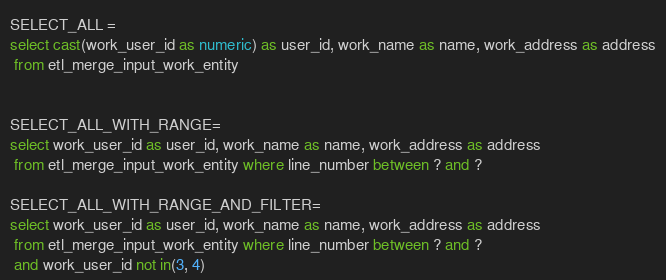<code> <loc_0><loc_0><loc_500><loc_500><_SQL_>SELECT_ALL =
select cast(work_user_id as numeric) as user_id, work_name as name, work_address as address
 from etl_merge_input_work_entity


SELECT_ALL_WITH_RANGE=
select work_user_id as user_id, work_name as name, work_address as address
 from etl_merge_input_work_entity where line_number between ? and ?

SELECT_ALL_WITH_RANGE_AND_FILTER=
select work_user_id as user_id, work_name as name, work_address as address
 from etl_merge_input_work_entity where line_number between ? and ?
 and work_user_id not in(3, 4)
</code> 